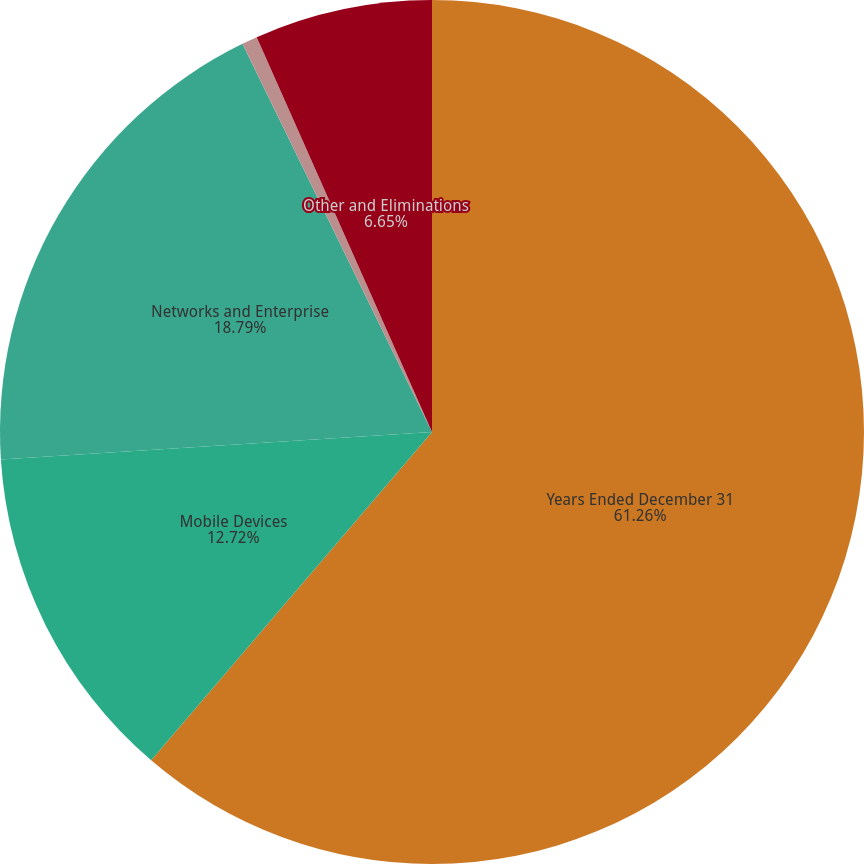Convert chart. <chart><loc_0><loc_0><loc_500><loc_500><pie_chart><fcel>Years Ended December 31<fcel>Mobile Devices<fcel>Networks and Enterprise<fcel>Connected Home Solutions<fcel>Other and Eliminations<nl><fcel>61.27%<fcel>12.72%<fcel>18.79%<fcel>0.58%<fcel>6.65%<nl></chart> 